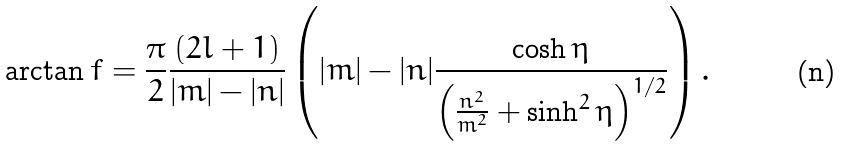<formula> <loc_0><loc_0><loc_500><loc_500>\arctan f = \frac { \pi } { 2 } \frac { ( 2 l + 1 ) } { | m | - | n | } \left ( | m | - | n | \frac { \cosh \eta } { \left ( \frac { n ^ { 2 } } { m ^ { 2 } } + \sinh ^ { 2 } \eta \right ) ^ { 1 / 2 } } \right ) .</formula> 